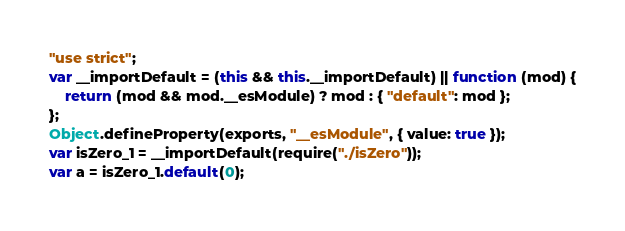Convert code to text. <code><loc_0><loc_0><loc_500><loc_500><_JavaScript_>"use strict";
var __importDefault = (this && this.__importDefault) || function (mod) {
    return (mod && mod.__esModule) ? mod : { "default": mod };
};
Object.defineProperty(exports, "__esModule", { value: true });
var isZero_1 = __importDefault(require("./isZero"));
var a = isZero_1.default(0);
</code> 